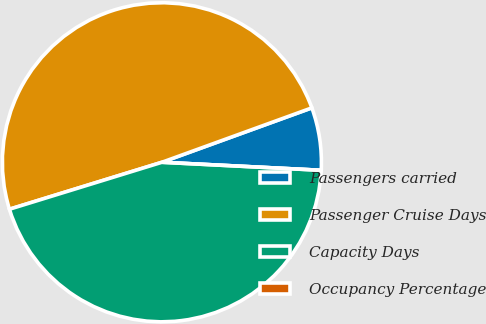Convert chart. <chart><loc_0><loc_0><loc_500><loc_500><pie_chart><fcel>Passengers carried<fcel>Passenger Cruise Days<fcel>Capacity Days<fcel>Occupancy Percentage<nl><fcel>6.34%<fcel>49.21%<fcel>44.44%<fcel>0.0%<nl></chart> 